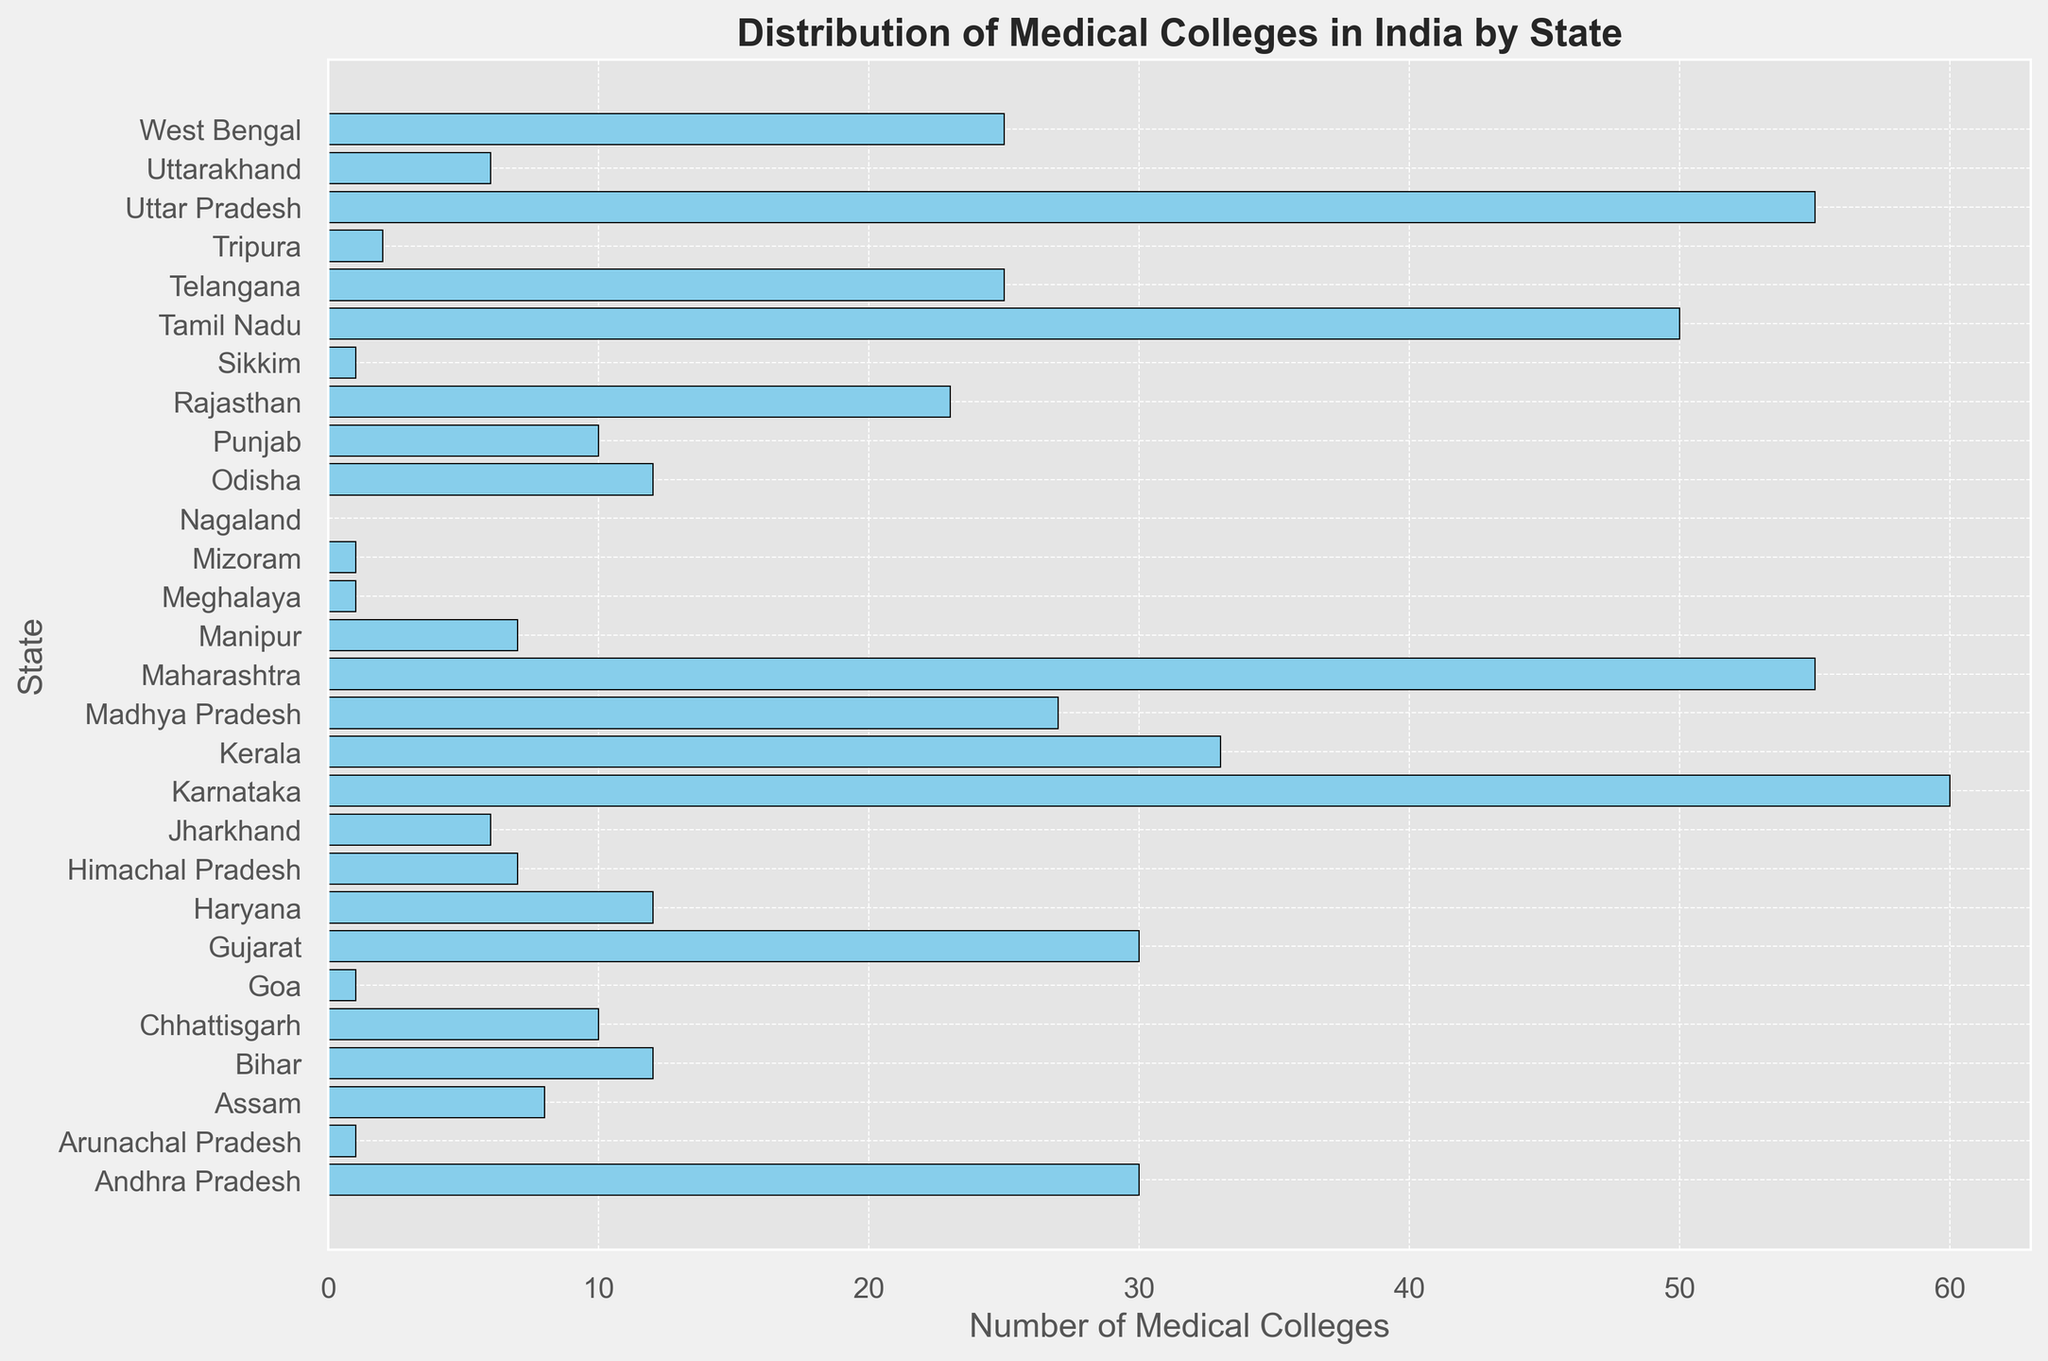Which state has the highest number of medical colleges? The state with the highest bar represents the highest number of medical colleges. By observing the height of the bars, Karnataka has the highest number of medical colleges.
Answer: Karnataka Which states have only one medical college? Identify the bars representing the value of one. The states with one medical college are Arunachal Pradesh, Goa, Meghalaya, Mizoram, and Sikkim.
Answer: Arunachal Pradesh, Goa, Meghalaya, Mizoram, Sikkim How many more medical colleges does Maharashtra have compared to Gujarat? Subtract the number of medical colleges in Gujarat from the number in Maharashtra. Maharashtra has 55, and Gujarat has 30, so 55 - 30 = 25.
Answer: 25 What is the combined total of medical colleges in Tamil Nadu and Telangana? Sum the number of medical colleges in Tamil Nadu and Telangana. Tamil Nadu has 50 and Telangana has 25, so 50 + 25 = 75.
Answer: 75 Which states have an equal number of medical colleges as Odisha? Identify the states with a bar equal in height to Odisha's bar. Odisha has 12 medical colleges, and the states with an equal number are Bihar and Haryana.
Answer: Bihar, Haryana Among Uttar Pradesh, Kerala, and Madhya Pradesh, which state has the smallest number of medical colleges? Compare the heights of the bars for Uttar Pradesh, Kerala, and Madhya Pradesh. Kerala has 33, Uttar Pradesh has 55, and Madhya Pradesh has 27, so Madhya Pradesh has the smallest number.
Answer: Madhya Pradesh What is the average number of medical colleges in Karnataka, Tamil Nadu, and Maharashtra? Sum the number of medical colleges in Karnataka, Tamil Nadu, and Maharashtra, and then divide by 3. Karnataka has 60, Tamil Nadu has 50, and Maharashtra has 55. The sum is 60 + 50 + 55 = 165, and the average is 165 / 3 = 55.
Answer: 55 How many medical colleges are there in total in the northeastern states (Arunachal Pradesh, Assam, Manipur, Meghalaya, Mizoram, Nagaland, Sikkim, Tripura)? Sum the number of medical colleges in each of these northeastern states. Arunachal Pradesh has 1, Assam has 8, Manipur has 7, Meghalaya has 1, Mizoram has 1, Nagaland has 0, Sikkim has 1, and Tripura has 2. The sum is 1 + 8 + 7 + 1 + 1 + 0 + 1 + 2 = 21.
Answer: 21 Compare the number of medical colleges between Haryana and Bihar. Which state has more? Observe the bars for Haryana and Bihar. Both have the same number of medical colleges, which is 12.
Answer: They are equal 